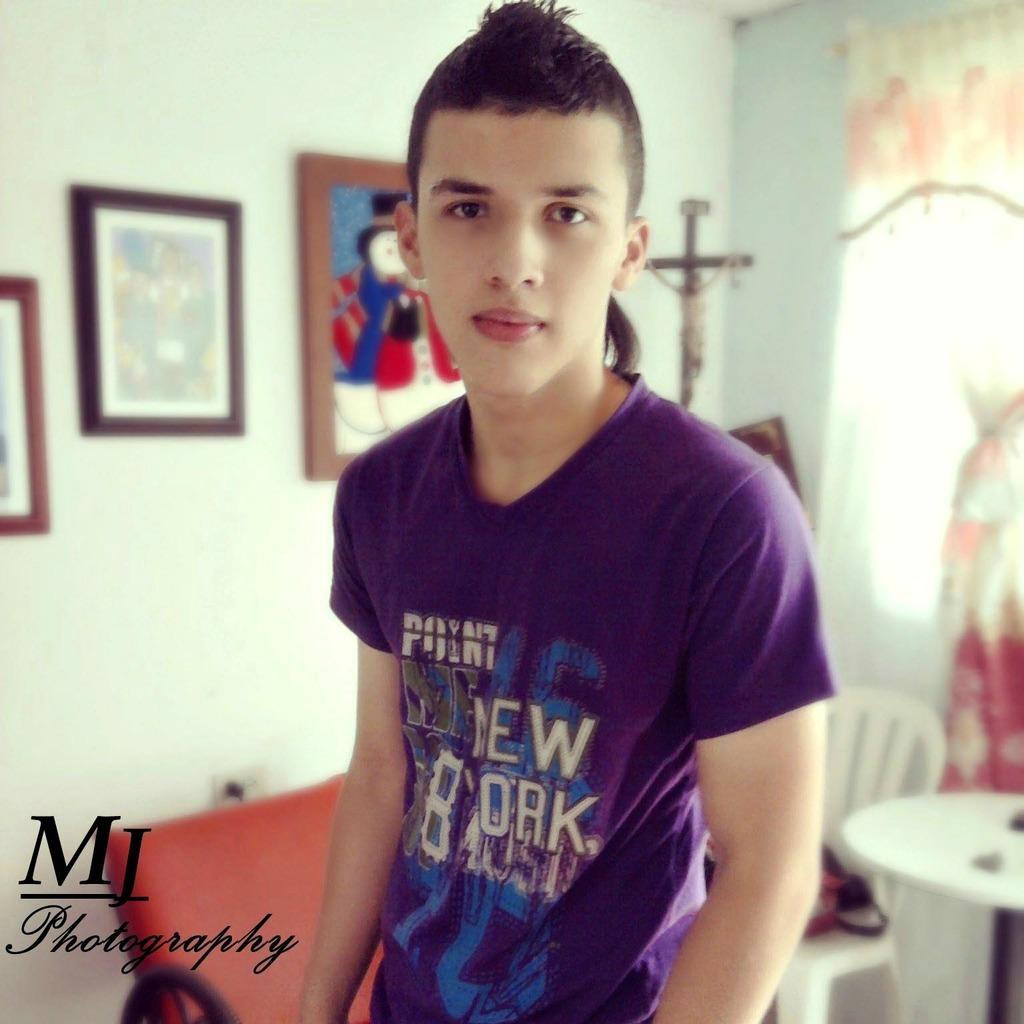Can you describe this image briefly? Here we can see a person. There is a table and a chair. In the background we can see frames and a wall. 